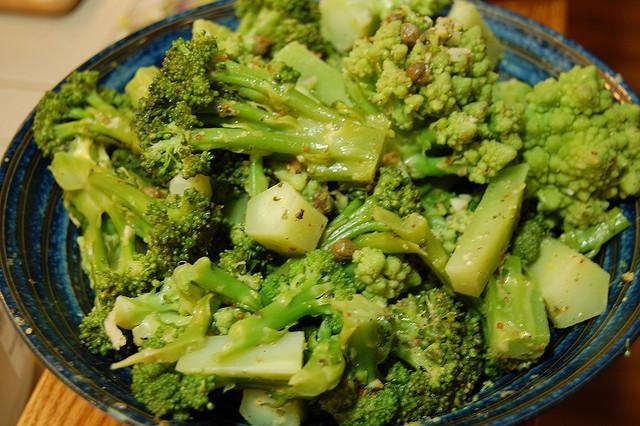Is the broccoli tasty?
Give a very brief answer. Yes. Is this food healthy?
Keep it brief. Yes. What type of food is this?
Concise answer only. Broccoli. Is there bacon in this dish?
Concise answer only. No. What color is the dish that the broccoli is being served on?
Answer briefly. Blue. 